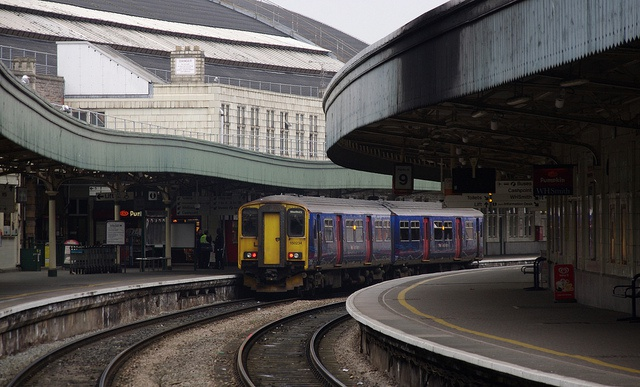Describe the objects in this image and their specific colors. I can see train in lightgray, black, gray, darkgray, and navy tones, bench in lightgray, black, gray, and darkblue tones, bench in lightgray, black, and gray tones, people in black and lightgray tones, and bench in lightgray, black, and gray tones in this image. 